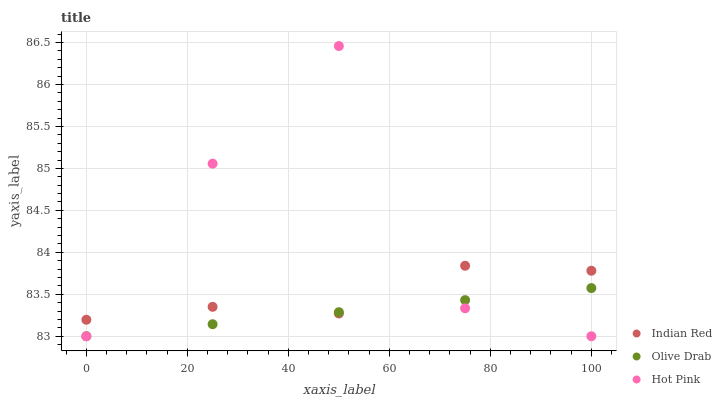Does Olive Drab have the minimum area under the curve?
Answer yes or no. Yes. Does Hot Pink have the maximum area under the curve?
Answer yes or no. Yes. Does Indian Red have the minimum area under the curve?
Answer yes or no. No. Does Indian Red have the maximum area under the curve?
Answer yes or no. No. Is Olive Drab the smoothest?
Answer yes or no. Yes. Is Hot Pink the roughest?
Answer yes or no. Yes. Is Indian Red the smoothest?
Answer yes or no. No. Is Indian Red the roughest?
Answer yes or no. No. Does Hot Pink have the lowest value?
Answer yes or no. Yes. Does Indian Red have the lowest value?
Answer yes or no. No. Does Hot Pink have the highest value?
Answer yes or no. Yes. Does Indian Red have the highest value?
Answer yes or no. No. Does Olive Drab intersect Hot Pink?
Answer yes or no. Yes. Is Olive Drab less than Hot Pink?
Answer yes or no. No. Is Olive Drab greater than Hot Pink?
Answer yes or no. No. 